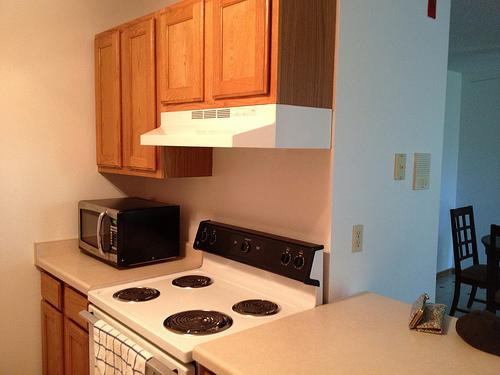Write a terse statement describing the essential subject of the image and its context. A black and silver microwave sits on the kitchen countertop surrounded by wooden cabinets and a white stovetop. Briefly describe the scene depicted in the image, mentioning the primary and secondary objects. The image portrays a tidy kitchen scene with a microwave as the main subject, accompanied by a stove, cabinets, a towel, and a wallet on the countertop as secondary elements. Briefly explain the central theme present in the image. The image showcases a well-equipped kitchen featuring a microwave, stove, cabinets, and various other kitchen items. Provide a concise description of the primary object and its surrounding environment in the image. A black and silver microwave is placed on the counter in the corner of a kitchen with wooden cabinets and a white stovetop. Express the main subject and some significant details from the image in a short phrase. Microwave in corner kitchen, wooden cabinets, stovetop, towel, and wallet on countertop. Write a brief statement summarizing the most essential details of the image. A well-organized kitchen features a microwave, stove, wooden cabinets, a towel on an oven handle, and a wallet on the countertop. Create a vivid description of a noteworthy aspect of the image. The image captures a cozy kitchen scene, complete with a black and silver microwave resting on the counter in the corner, surrounded by wooden cabinets and a white, clean stovetop. Describe the image focusing on the dominant object and its function. In the image, a black and silver microwave is positioned on the kitchen counter, ready to efficiently heat meals and beverages. Mention the most prominent object in the image along with its location and appearance. The black and silver microwave situated on the countertop in the corner of the kitchen is the most prominent object. Enumerate the significant elements of the image in a single sentence. The image comprises of a microwave, stove, cabinets, kitchen drawers, a wallet on the countertop, a towel on the oven handle, and a chair by the table. 